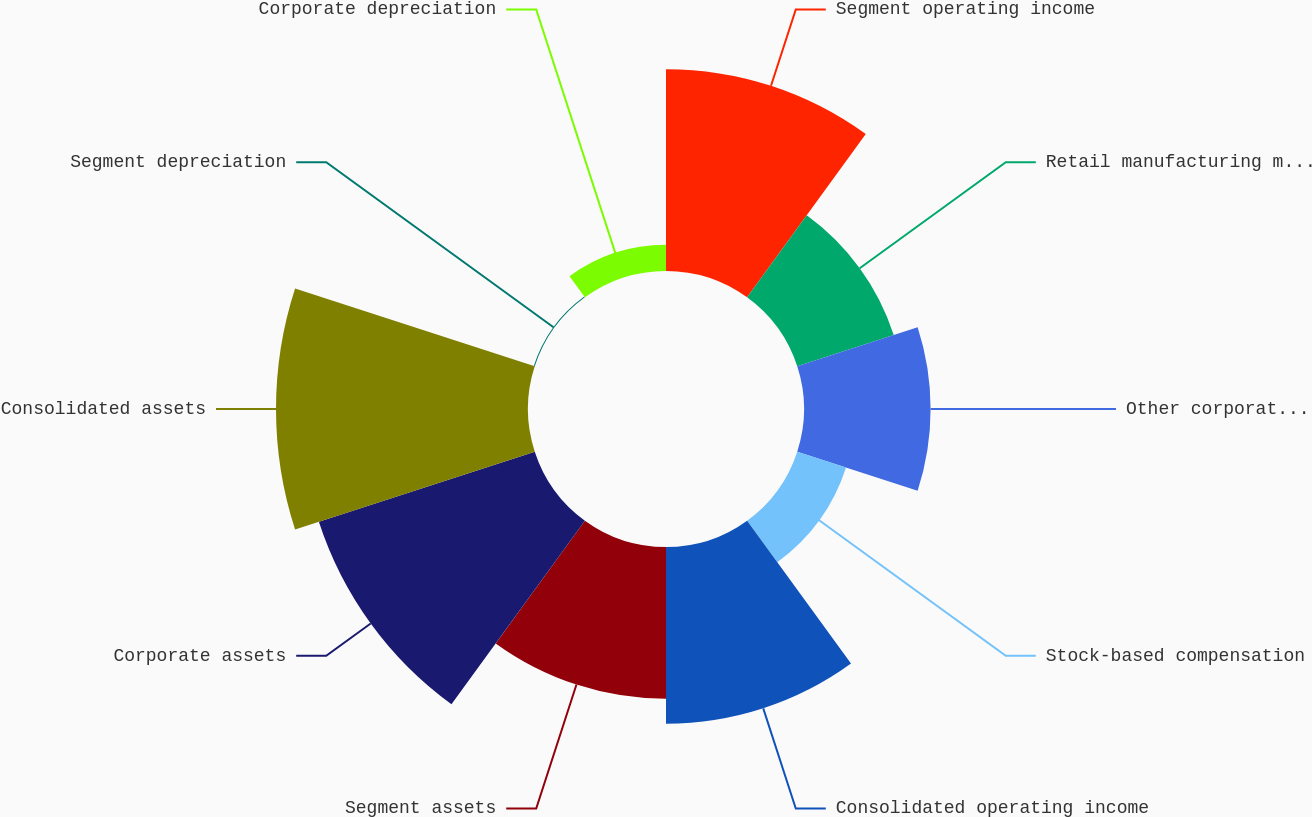Convert chart to OTSL. <chart><loc_0><loc_0><loc_500><loc_500><pie_chart><fcel>Segment operating income<fcel>Retail manufacturing margin<fcel>Other corporate expenses net<fcel>Stock-based compensation<fcel>Consolidated operating income<fcel>Segment assets<fcel>Corporate assets<fcel>Consolidated assets<fcel>Segment depreciation<fcel>Corporate depreciation<nl><fcel>15.34%<fcel>7.71%<fcel>9.62%<fcel>3.9%<fcel>13.43%<fcel>11.53%<fcel>17.25%<fcel>19.15%<fcel>0.08%<fcel>1.99%<nl></chart> 